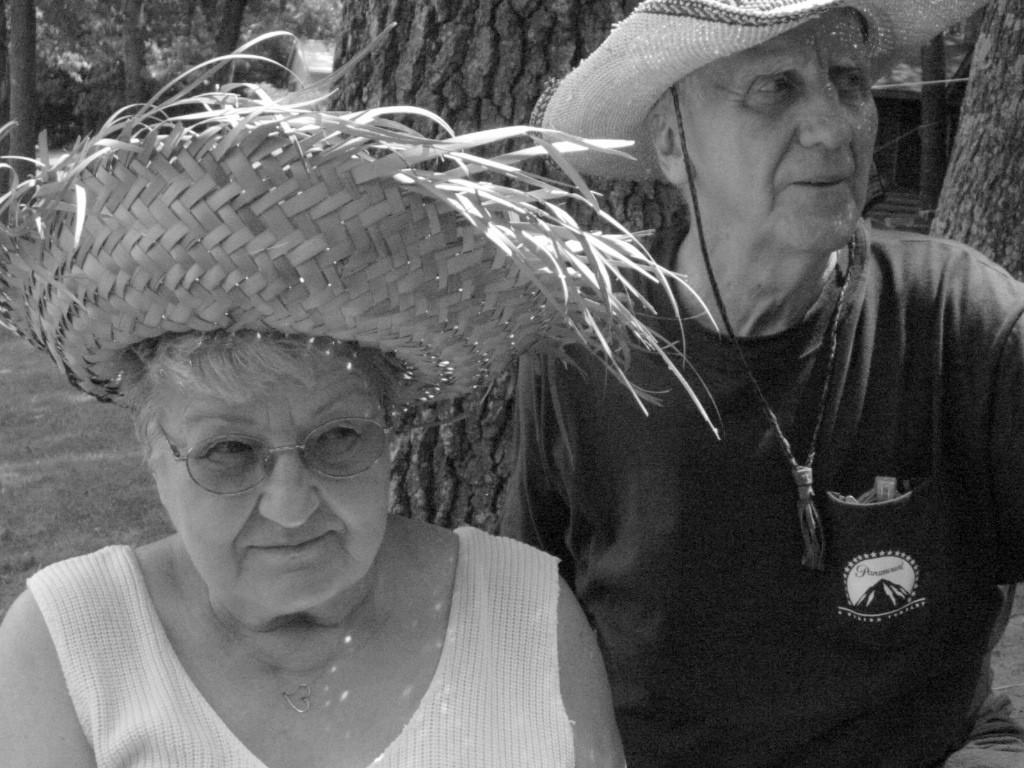Describe this image in one or two sentences. In this image we can see two people wearing hats. And we can see the surrounding trees. 